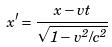Convert formula to latex. <formula><loc_0><loc_0><loc_500><loc_500>x ^ { \prime } = \frac { x - v t } { \sqrt { 1 - v ^ { 2 } / c ^ { 2 } } }</formula> 